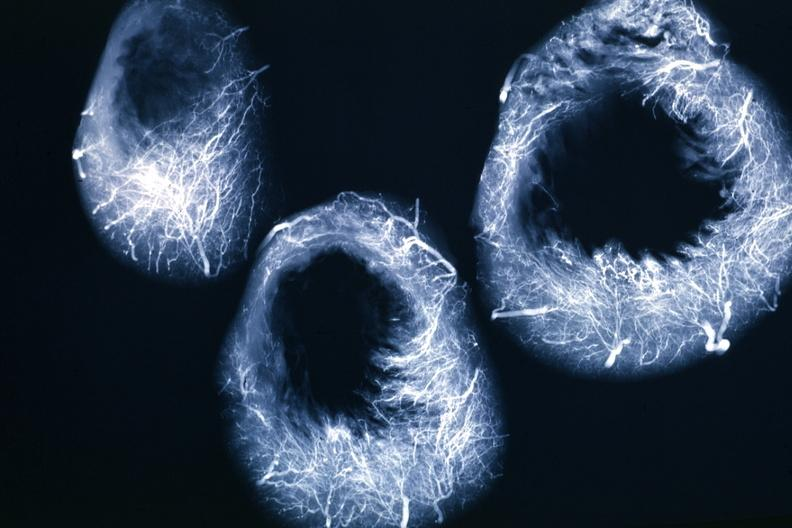what is present?
Answer the question using a single word or phrase. Angiogram 